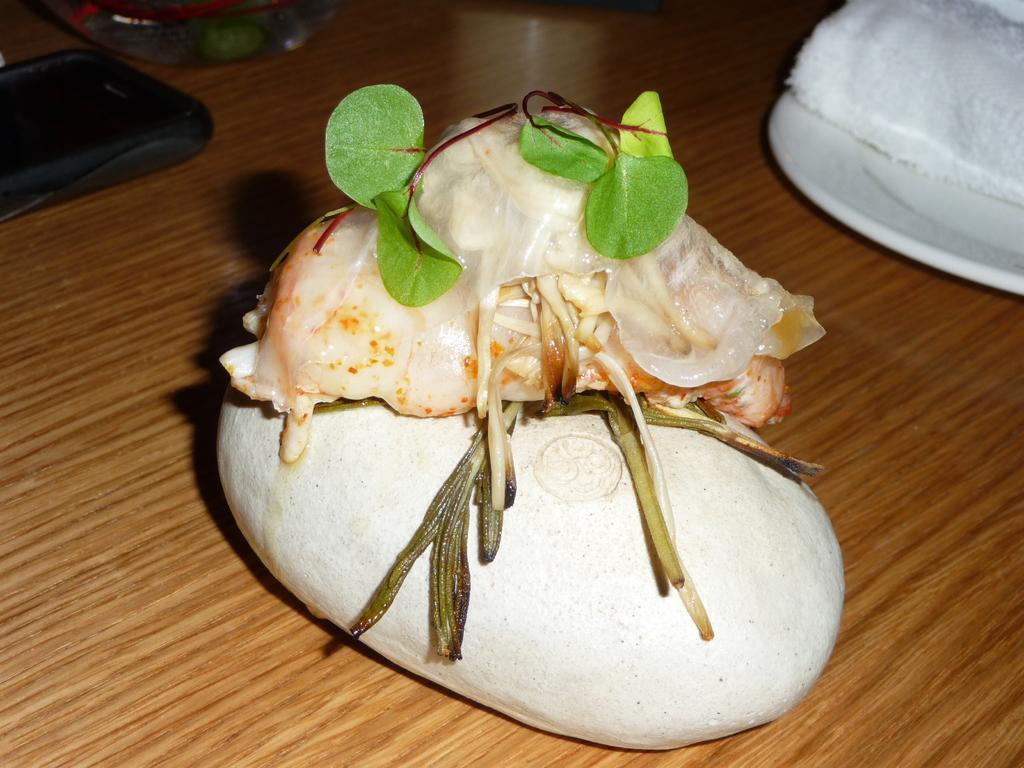Describe this image in one or two sentences. In the picture we can see some food items are placed on a wooden table. Here we can see a mobile phone and few more objects are placed on a wooden table. 